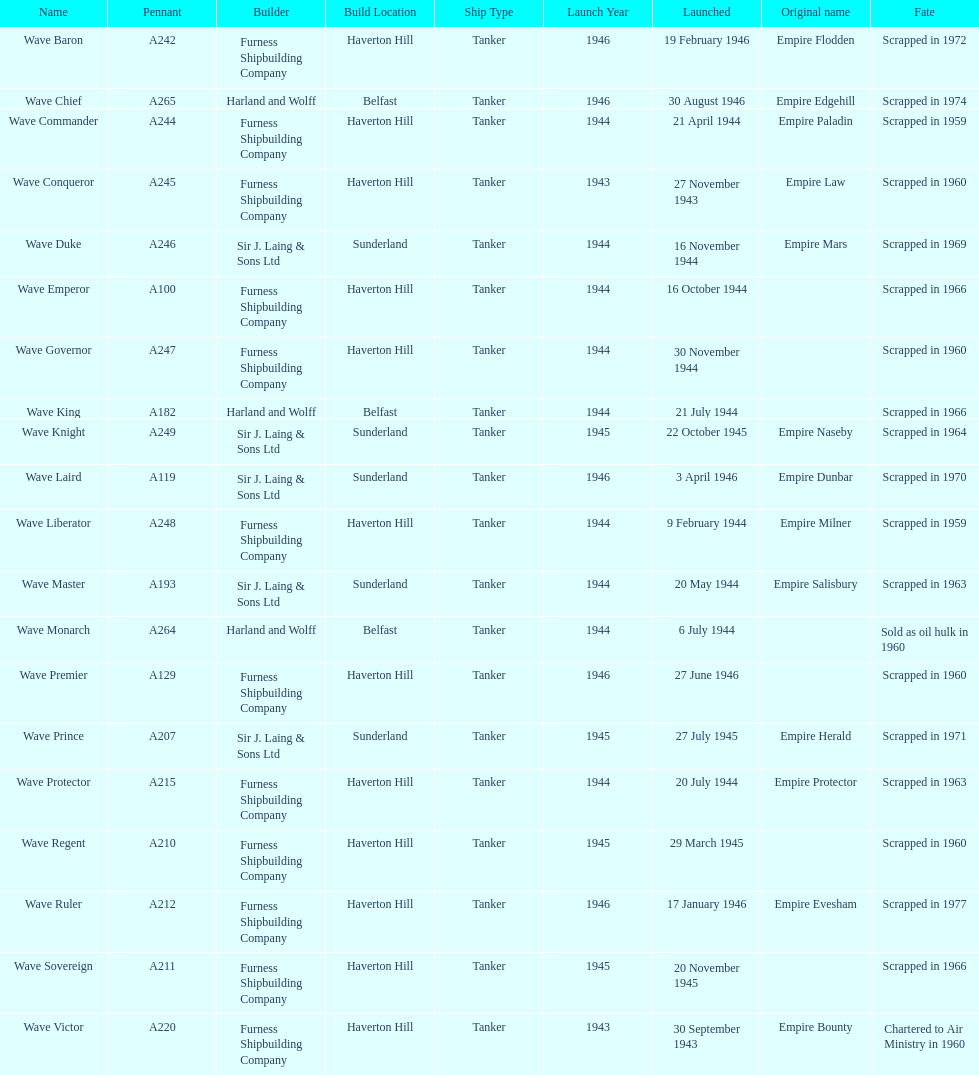List a construction company featuring "and" within their title. Harland and Wolff. 